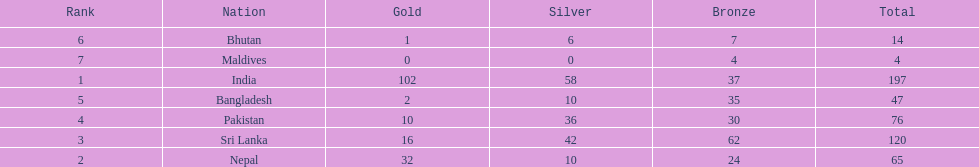What is the difference between the nation with the most medals and the nation with the least amount of medals? 193. 